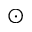Convert formula to latex. <formula><loc_0><loc_0><loc_500><loc_500>_ { \odot }</formula> 